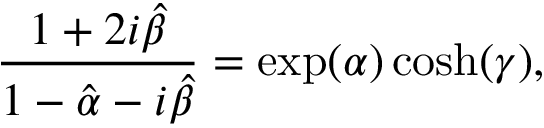<formula> <loc_0><loc_0><loc_500><loc_500>\frac { 1 + 2 i \hat { \beta } } { 1 - \hat { \alpha } - i \hat { \beta } } = \exp ( \alpha ) \cosh ( \gamma ) ,</formula> 